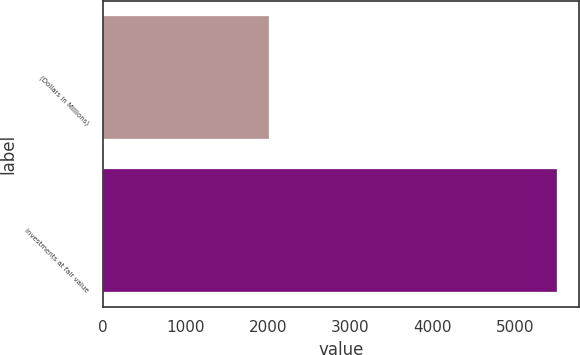<chart> <loc_0><loc_0><loc_500><loc_500><bar_chart><fcel>(Dollars in Millions)<fcel>Investments at fair value<nl><fcel>2018<fcel>5502<nl></chart> 